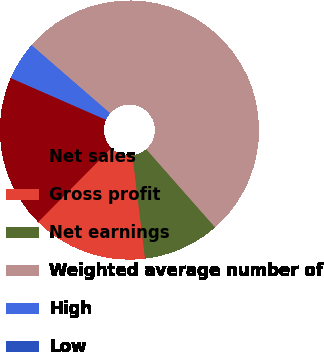<chart> <loc_0><loc_0><loc_500><loc_500><pie_chart><fcel>Net sales<fcel>Gross profit<fcel>Net earnings<fcel>Weighted average number of<fcel>High<fcel>Low<nl><fcel>19.15%<fcel>14.36%<fcel>9.57%<fcel>52.14%<fcel>4.79%<fcel>0.0%<nl></chart> 